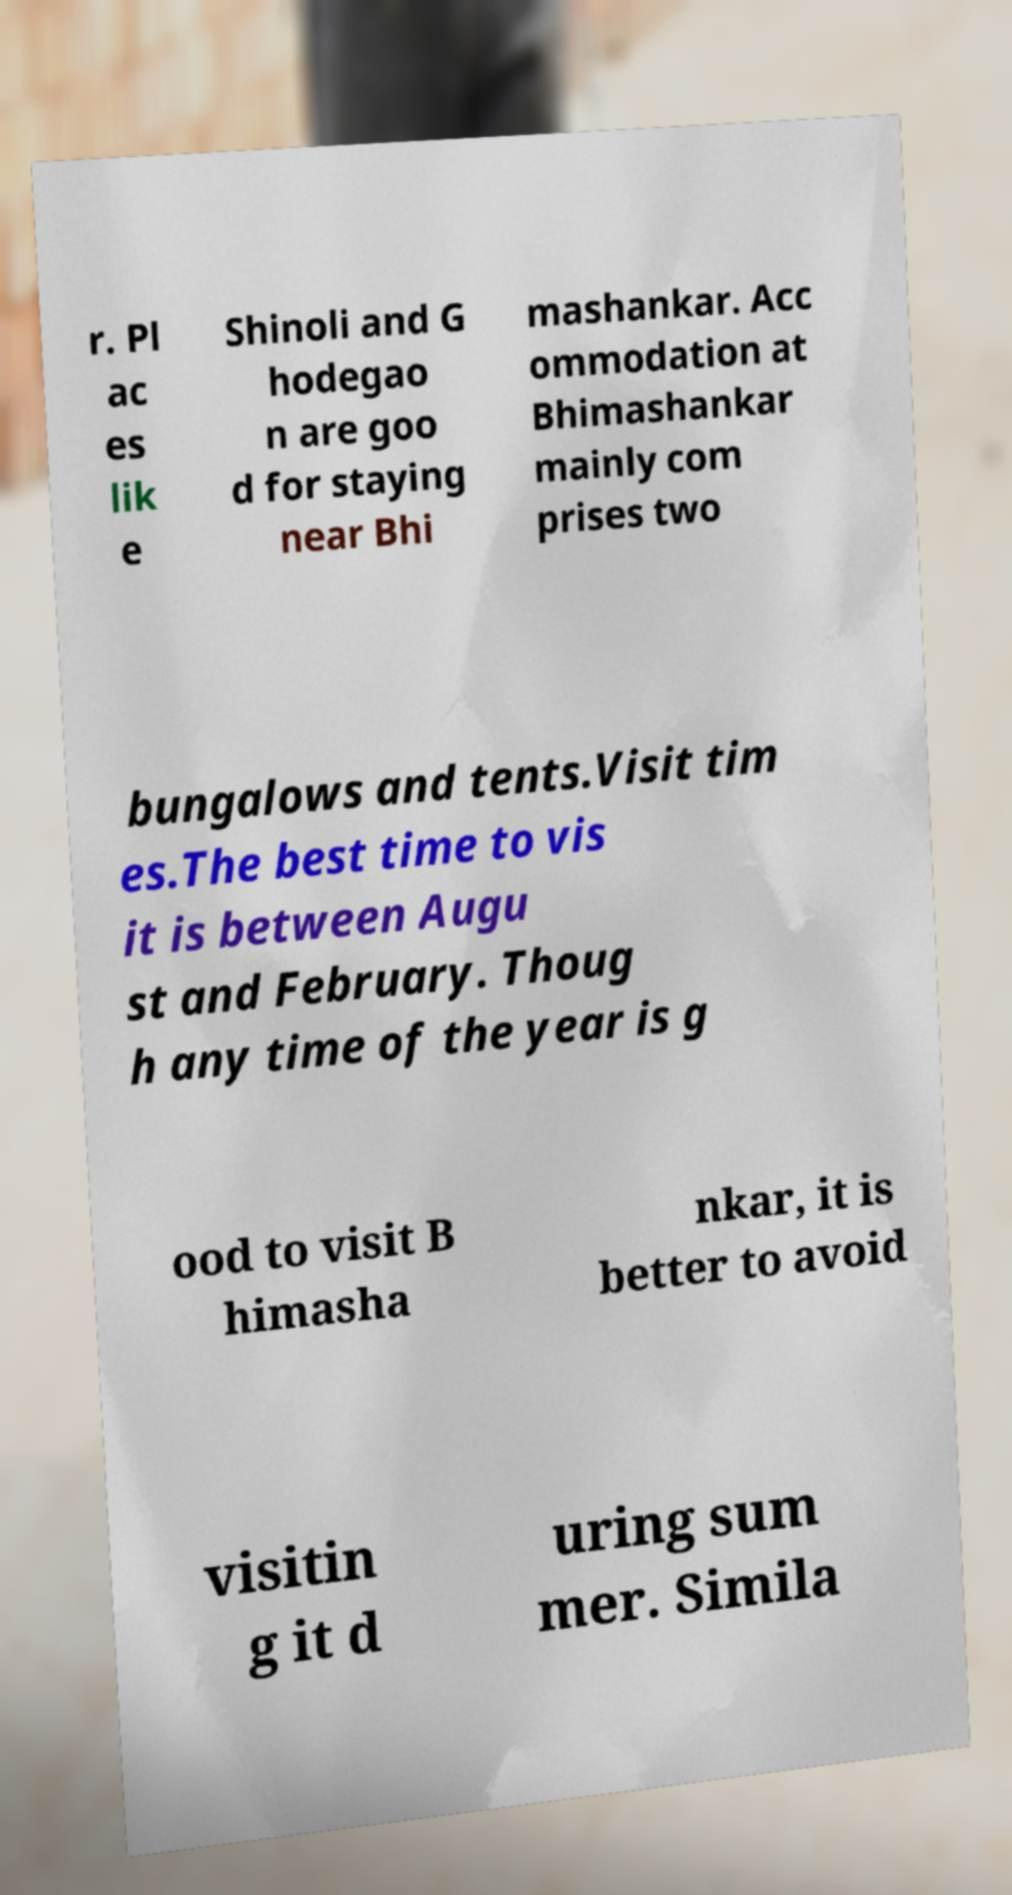Could you assist in decoding the text presented in this image and type it out clearly? r. Pl ac es lik e Shinoli and G hodegao n are goo d for staying near Bhi mashankar. Acc ommodation at Bhimashankar mainly com prises two bungalows and tents.Visit tim es.The best time to vis it is between Augu st and February. Thoug h any time of the year is g ood to visit B himasha nkar, it is better to avoid visitin g it d uring sum mer. Simila 